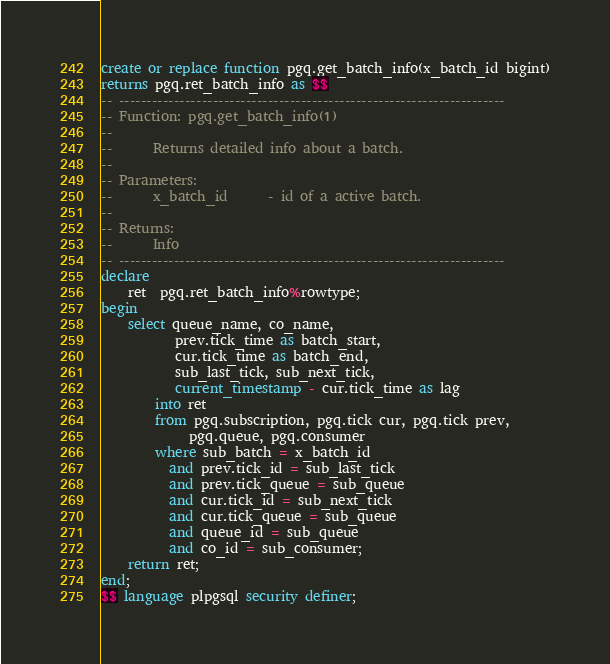Convert code to text. <code><loc_0><loc_0><loc_500><loc_500><_SQL_>
create or replace function pgq.get_batch_info(x_batch_id bigint)
returns pgq.ret_batch_info as $$
-- ----------------------------------------------------------------------
-- Function: pgq.get_batch_info(1)
--
--      Returns detailed info about a batch.
--
-- Parameters:
--      x_batch_id      - id of a active batch.
--
-- Returns:
--      Info
-- ----------------------------------------------------------------------
declare
    ret  pgq.ret_batch_info%rowtype;
begin
    select queue_name, co_name,
           prev.tick_time as batch_start,
           cur.tick_time as batch_end,
           sub_last_tick, sub_next_tick,
           current_timestamp - cur.tick_time as lag
        into ret
        from pgq.subscription, pgq.tick cur, pgq.tick prev,
             pgq.queue, pgq.consumer
        where sub_batch = x_batch_id
          and prev.tick_id = sub_last_tick
          and prev.tick_queue = sub_queue
          and cur.tick_id = sub_next_tick
          and cur.tick_queue = sub_queue
          and queue_id = sub_queue
          and co_id = sub_consumer;
    return ret;
end;
$$ language plpgsql security definer;

</code> 